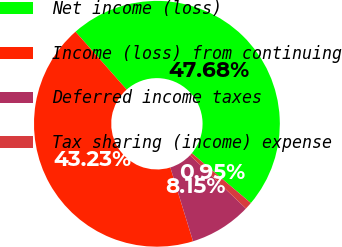Convert chart. <chart><loc_0><loc_0><loc_500><loc_500><pie_chart><fcel>Net income (loss)<fcel>Income (loss) from continuing<fcel>Deferred income taxes<fcel>Tax sharing (income) expense<nl><fcel>47.68%<fcel>43.23%<fcel>8.15%<fcel>0.95%<nl></chart> 